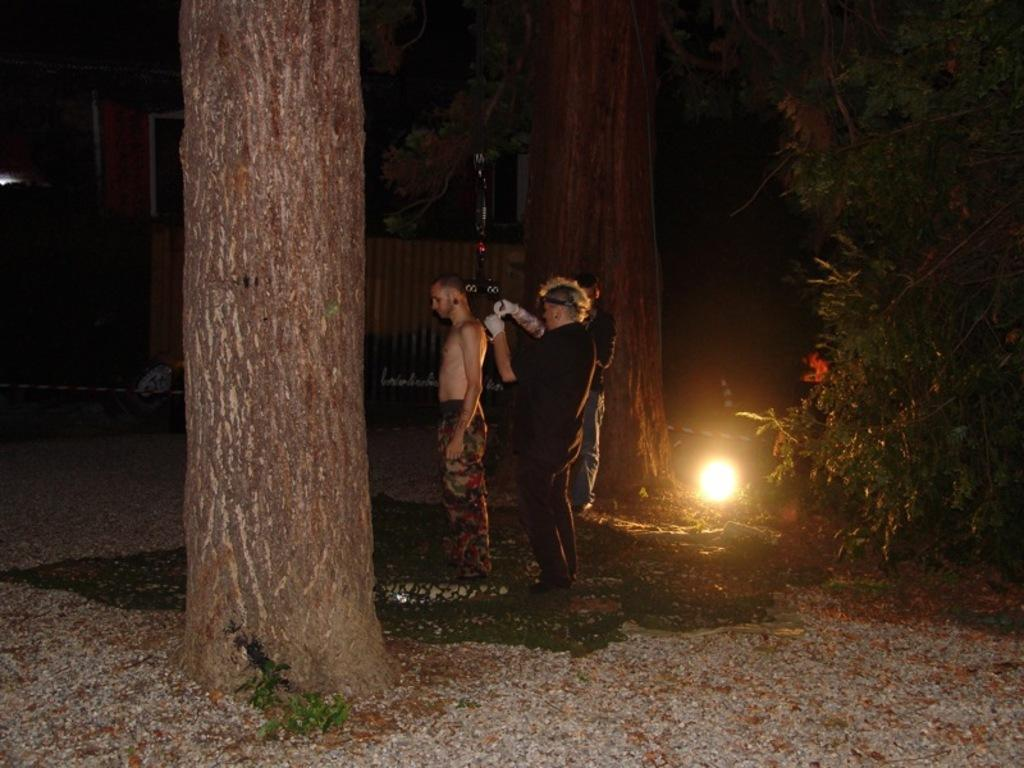How many people are in the image? There is a group of people in the image, but the exact number is not specified. What is the position of the people in the image? The people are standing on the ground in the image. What can be seen in the image besides the people? There is a light and trees visible in the image. What type of religious ceremony is taking place in the image? There is no indication of a religious ceremony in the image; it simply shows a group of people standing on the ground with a light and trees nearby. 